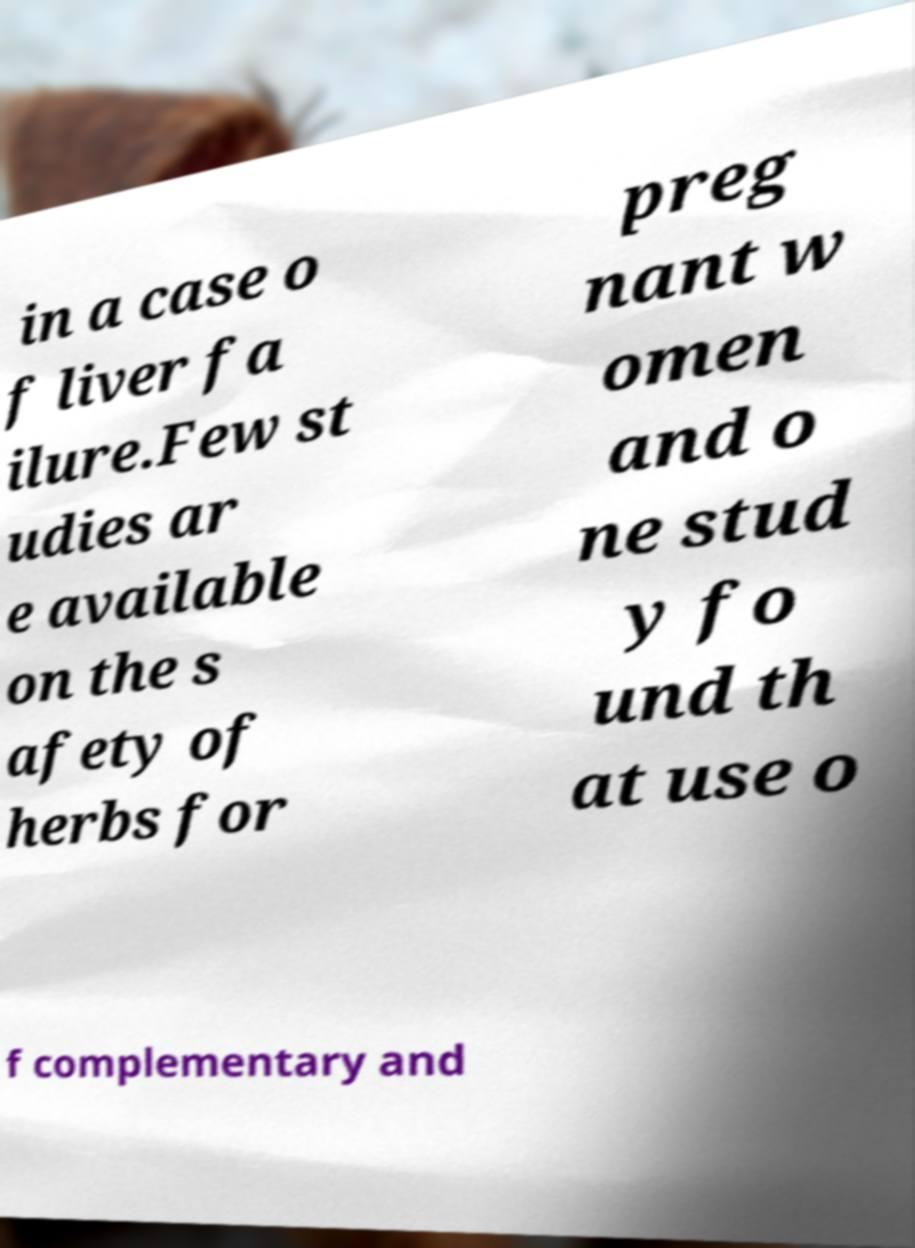Could you assist in decoding the text presented in this image and type it out clearly? in a case o f liver fa ilure.Few st udies ar e available on the s afety of herbs for preg nant w omen and o ne stud y fo und th at use o f complementary and 